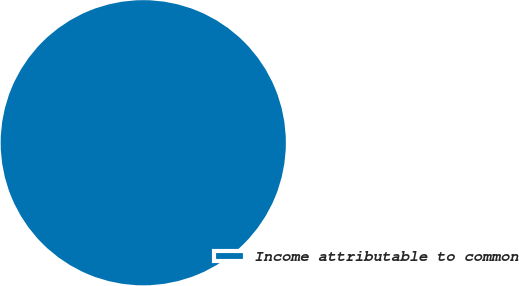<chart> <loc_0><loc_0><loc_500><loc_500><pie_chart><fcel>Income attributable to common<nl><fcel>100.0%<nl></chart> 